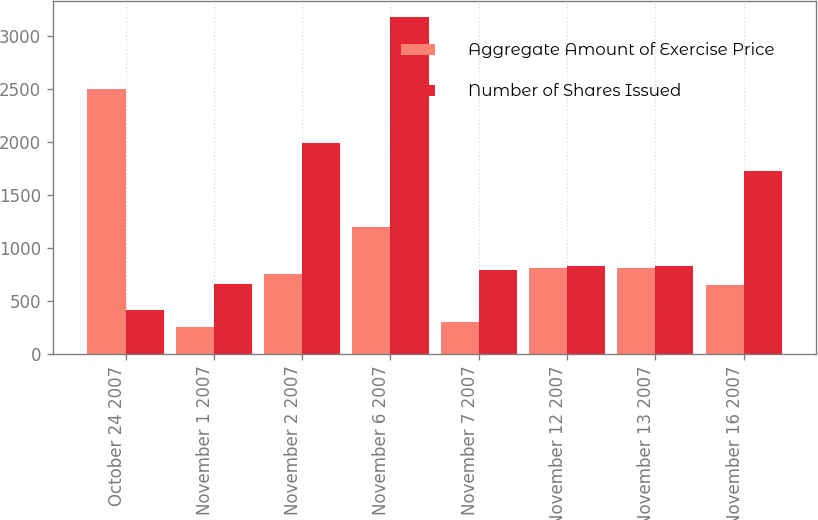Convert chart to OTSL. <chart><loc_0><loc_0><loc_500><loc_500><stacked_bar_chart><ecel><fcel>October 24 2007<fcel>November 1 2007<fcel>November 2 2007<fcel>November 6 2007<fcel>November 7 2007<fcel>November 12 2007<fcel>November 13 2007<fcel>November 16 2007<nl><fcel>Aggregate Amount of Exercise Price<fcel>2500<fcel>250<fcel>750<fcel>1200<fcel>300<fcel>814<fcel>814<fcel>650<nl><fcel>Number of Shares Issued<fcel>417<fcel>662<fcel>1988<fcel>3180<fcel>795<fcel>833<fcel>833<fcel>1723<nl></chart> 